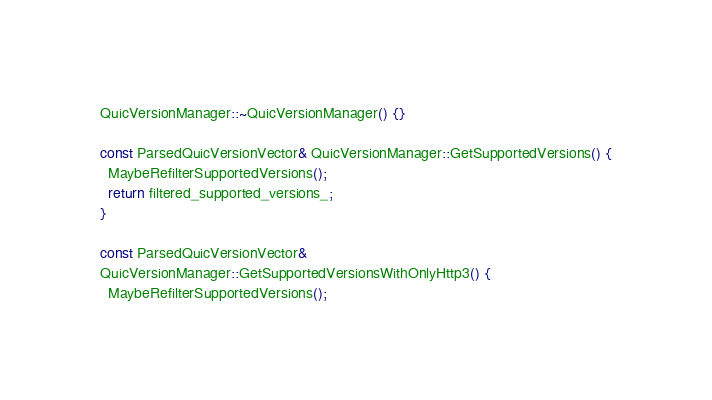Convert code to text. <code><loc_0><loc_0><loc_500><loc_500><_C++_>
QuicVersionManager::~QuicVersionManager() {}

const ParsedQuicVersionVector& QuicVersionManager::GetSupportedVersions() {
  MaybeRefilterSupportedVersions();
  return filtered_supported_versions_;
}

const ParsedQuicVersionVector&
QuicVersionManager::GetSupportedVersionsWithOnlyHttp3() {
  MaybeRefilterSupportedVersions();</code> 